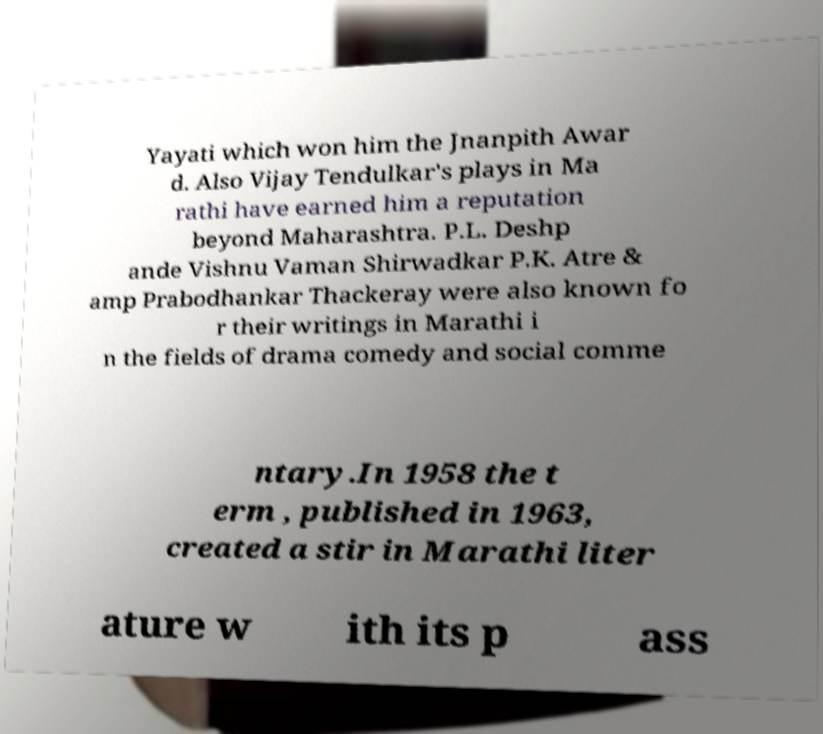I need the written content from this picture converted into text. Can you do that? Yayati which won him the Jnanpith Awar d. Also Vijay Tendulkar's plays in Ma rathi have earned him a reputation beyond Maharashtra. P.L. Deshp ande Vishnu Vaman Shirwadkar P.K. Atre & amp Prabodhankar Thackeray were also known fo r their writings in Marathi i n the fields of drama comedy and social comme ntary.In 1958 the t erm , published in 1963, created a stir in Marathi liter ature w ith its p ass 